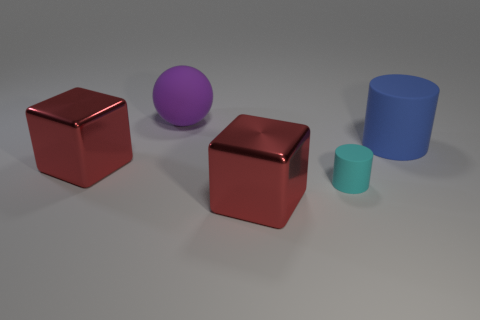Is there any other thing that is the same size as the cyan object?
Make the answer very short. No. What is the size of the red thing that is in front of the cylinder in front of the blue matte cylinder?
Give a very brief answer. Large. There is a big thing that is the same shape as the tiny object; what is it made of?
Give a very brief answer. Rubber. What number of other metallic objects are the same size as the blue object?
Your answer should be compact. 2. Does the blue matte cylinder have the same size as the purple thing?
Your answer should be compact. Yes. What is the size of the thing that is both behind the small cylinder and in front of the large blue cylinder?
Keep it short and to the point. Large. Are there more blue matte things in front of the blue matte object than large shiny cubes right of the purple matte sphere?
Ensure brevity in your answer.  No. There is another small object that is the same shape as the blue rubber thing; what is its color?
Offer a very short reply. Cyan. There is a cylinder that is in front of the blue object; is its color the same as the large cylinder?
Your response must be concise. No. How many red shiny cubes are there?
Ensure brevity in your answer.  2. 